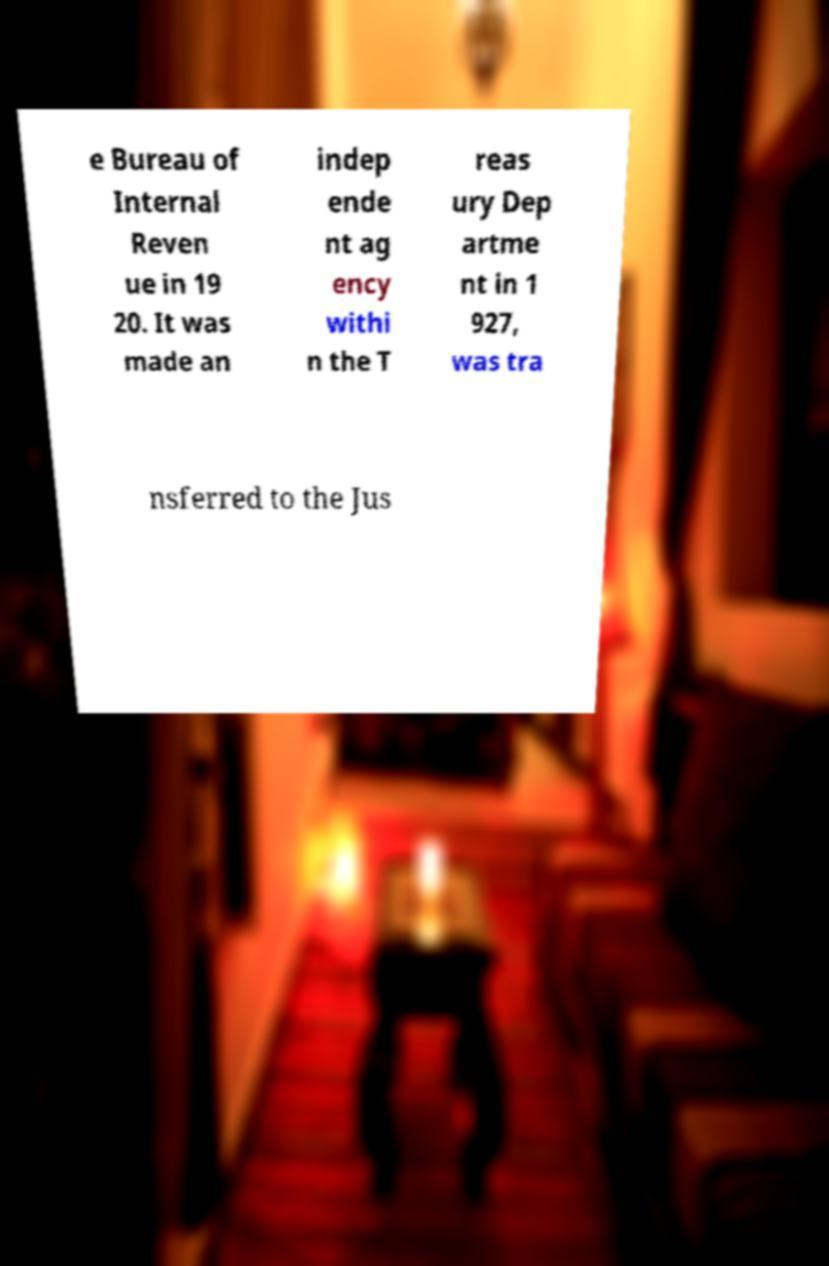I need the written content from this picture converted into text. Can you do that? e Bureau of Internal Reven ue in 19 20. It was made an indep ende nt ag ency withi n the T reas ury Dep artme nt in 1 927, was tra nsferred to the Jus 